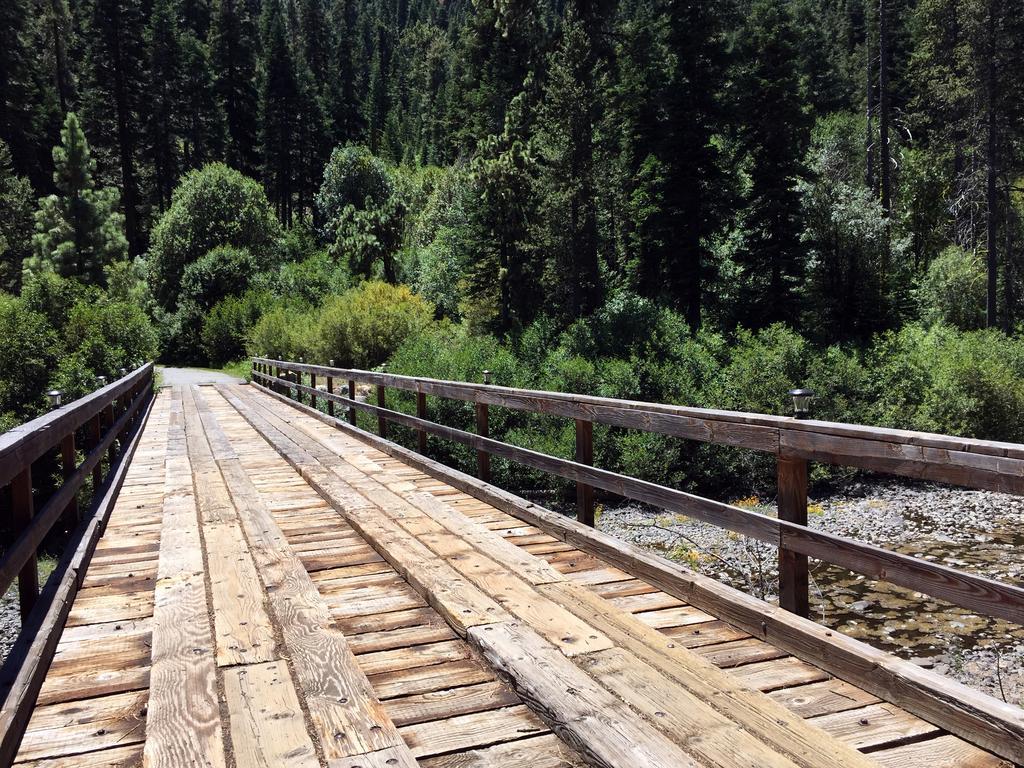Please provide a concise description of this image. In this image we can see a bridge and plants. In the background there are trees. 